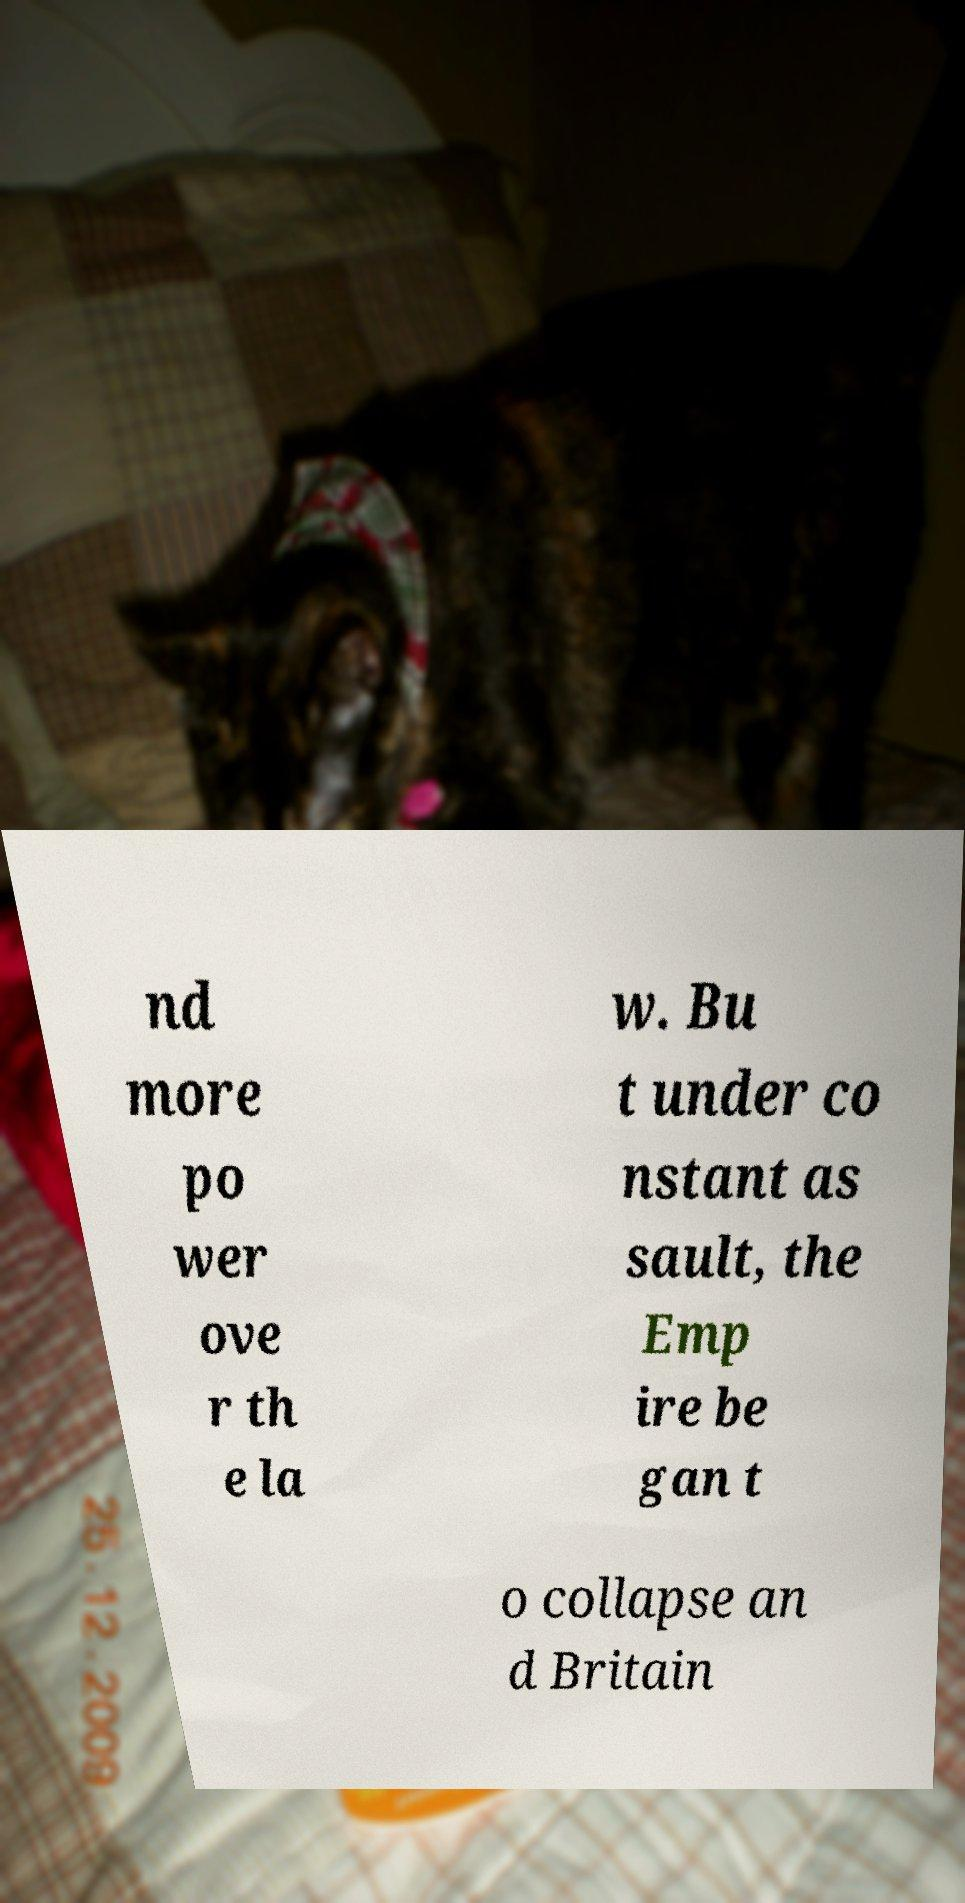Please identify and transcribe the text found in this image. nd more po wer ove r th e la w. Bu t under co nstant as sault, the Emp ire be gan t o collapse an d Britain 